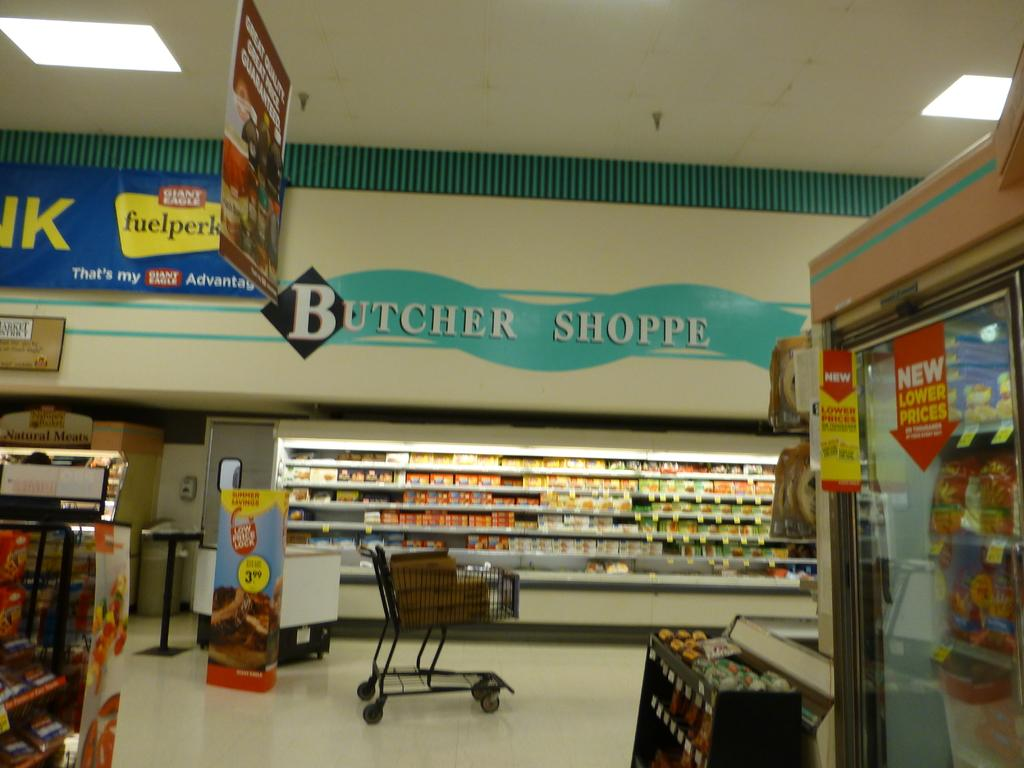<image>
Write a terse but informative summary of the picture. The butcher shoppe section in a Giant Eagle grocery store 